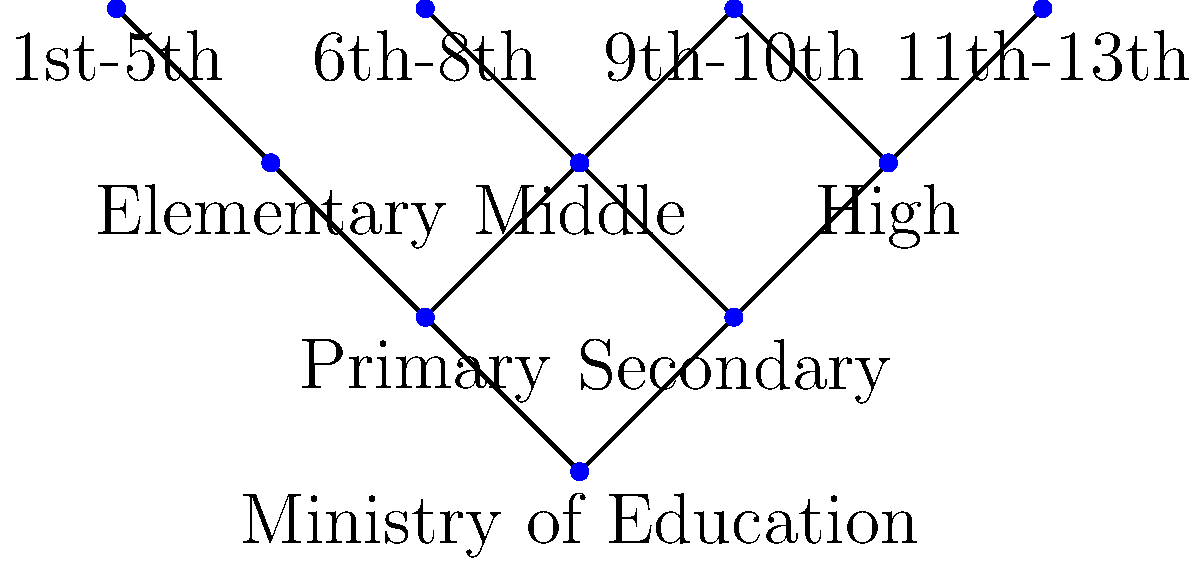Based on the network diagram representing Italy's educational system hierarchy, which level of education serves as a bridge between primary and secondary education, connecting to both elementary and high school levels? To answer this question, let's analyze the network diagram step-by-step:

1. The diagram shows a hierarchical structure of Italy's educational system.
2. At the top, we see the "Ministry of Education" node, which oversees the entire system.
3. Below the Ministry, the system splits into two main branches: "Primary" and "Secondary" education.
4. Under "Primary" education, we find "Elementary" (1st-5th grades).
5. Under "Secondary" education, we find "High" school (9th-10th and 11th-13th grades).
6. In between these two levels, we see a node labeled "Middle" that connects to both "Primary" and "Secondary" education.
7. This "Middle" level is further specified as 6th-8th grades.

The key observation is that the "Middle" level serves as a connection point between "Primary" and "Secondary" education. It links to both "Elementary" (which is part of Primary education) and "High" school (which is part of Secondary education).

Therefore, the level of education that serves as a bridge between primary and secondary education, connecting to both elementary and high school levels, is the "Middle" school level.
Answer: Middle school 